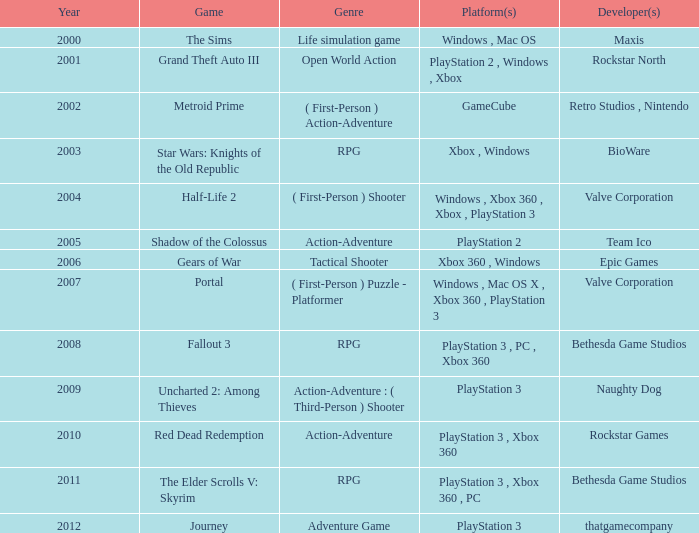What game was available in 2005? Shadow of the Colossus. 